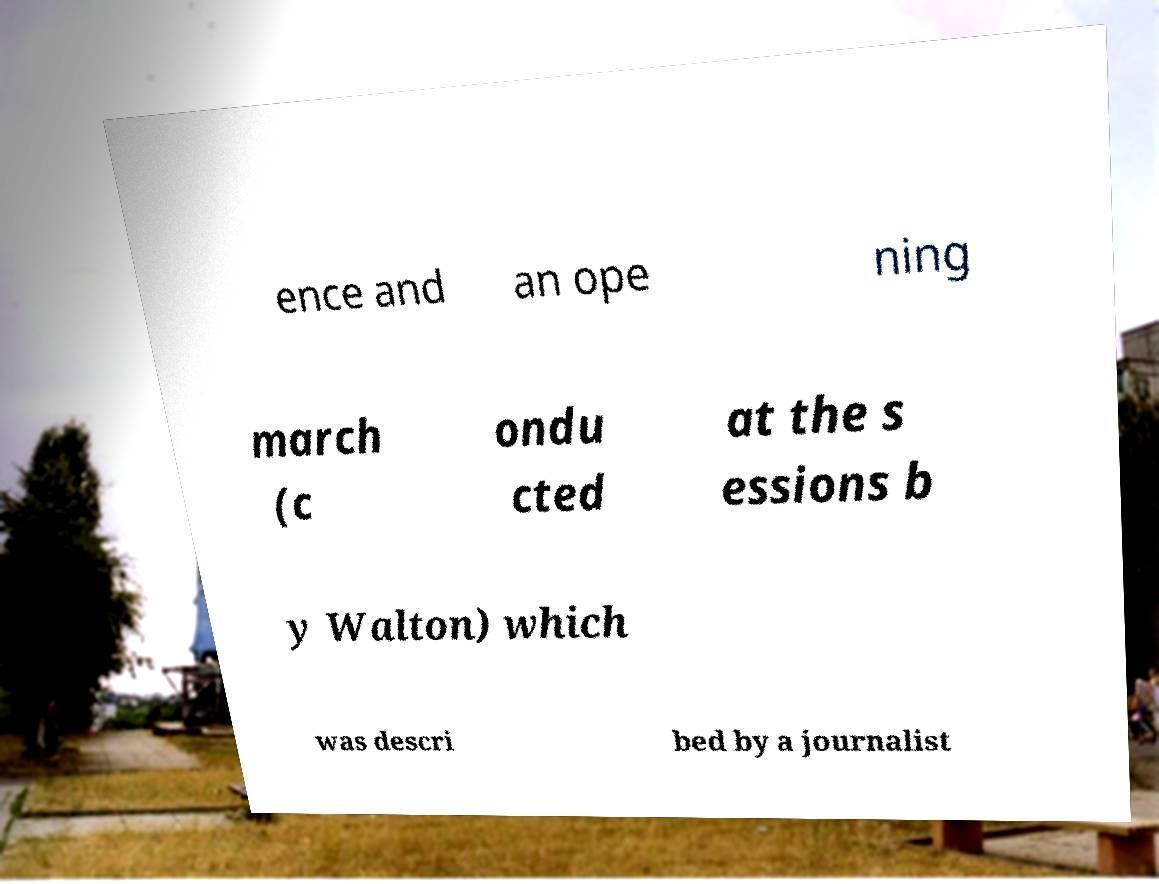Please read and relay the text visible in this image. What does it say? ence and an ope ning march (c ondu cted at the s essions b y Walton) which was descri bed by a journalist 